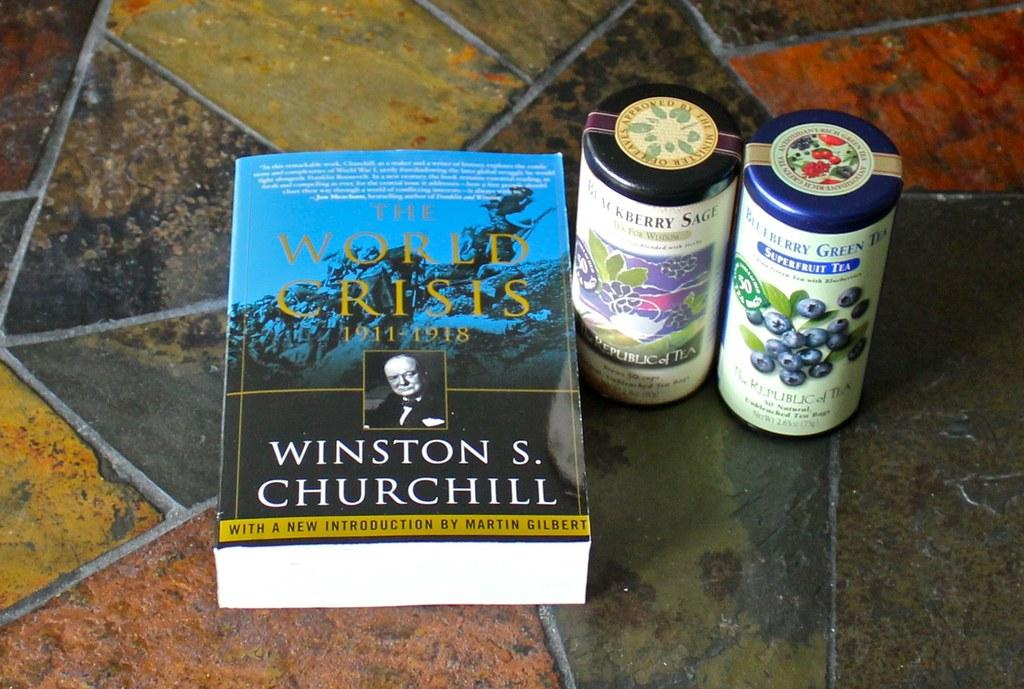Provide a one-sentence caption for the provided image. A book by Churchill sits next to two canisters of tea. 